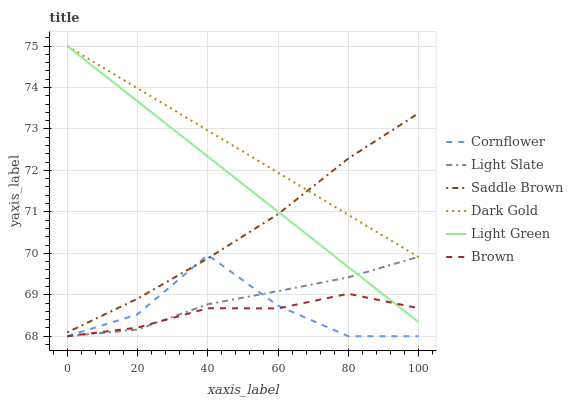Does Light Slate have the minimum area under the curve?
Answer yes or no. No. Does Light Slate have the maximum area under the curve?
Answer yes or no. No. Is Brown the smoothest?
Answer yes or no. No. Is Brown the roughest?
Answer yes or no. No. Does Dark Gold have the lowest value?
Answer yes or no. No. Does Light Slate have the highest value?
Answer yes or no. No. Is Cornflower less than Dark Gold?
Answer yes or no. Yes. Is Saddle Brown greater than Light Slate?
Answer yes or no. Yes. Does Cornflower intersect Dark Gold?
Answer yes or no. No. 